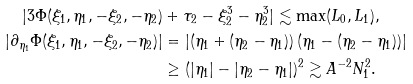<formula> <loc_0><loc_0><loc_500><loc_500>| 3 \Phi ( \xi _ { 1 } , \eta _ { 1 } , - \xi _ { 2 } , - \eta _ { 2 } ) & + \tau _ { 2 } - \xi _ { 2 } ^ { 3 } - \eta _ { 2 } ^ { 3 } | \lesssim \max ( L _ { 0 } , L _ { 1 } ) , \\ | \partial _ { \eta _ { 1 } } \Phi ( \xi _ { 1 } , \eta _ { 1 } , - \xi _ { 2 } , - \eta _ { 2 } ) | & = | ( \eta _ { 1 } + ( \eta _ { 2 } - \eta _ { 1 } ) ) \, ( \eta _ { 1 } - ( \eta _ { 2 } - \eta _ { 1 } ) ) | \\ & \geq ( | \eta _ { 1 } | - | \eta _ { 2 } - \eta _ { 1 } | ) ^ { 2 } \gtrsim A ^ { - 2 } N _ { 1 } ^ { 2 } .</formula> 